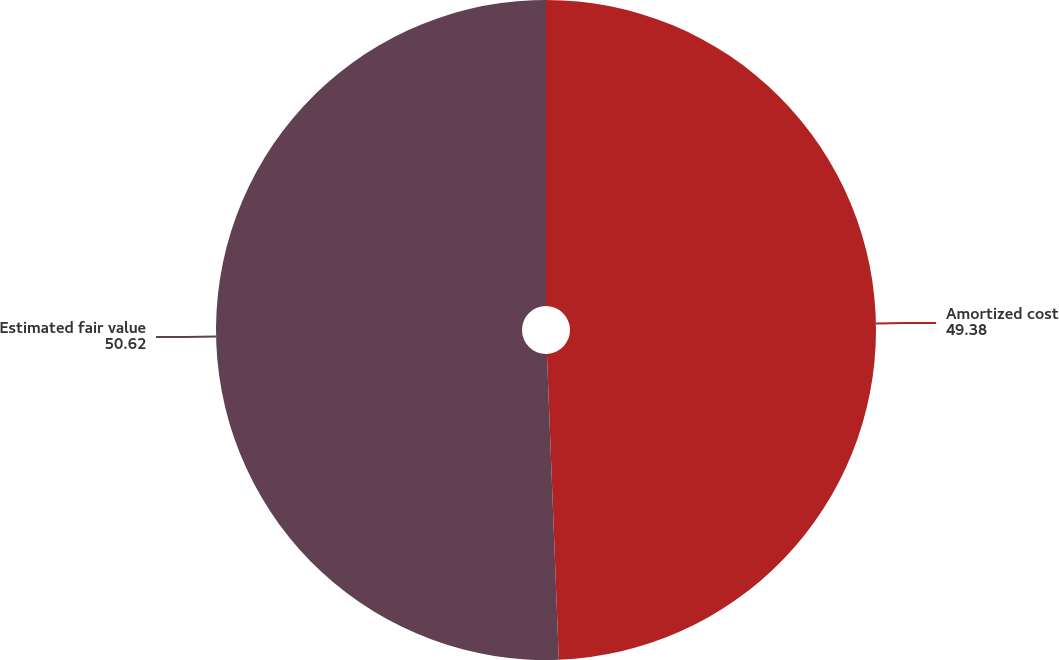<chart> <loc_0><loc_0><loc_500><loc_500><pie_chart><fcel>Amortized cost<fcel>Estimated fair value<nl><fcel>49.38%<fcel>50.62%<nl></chart> 